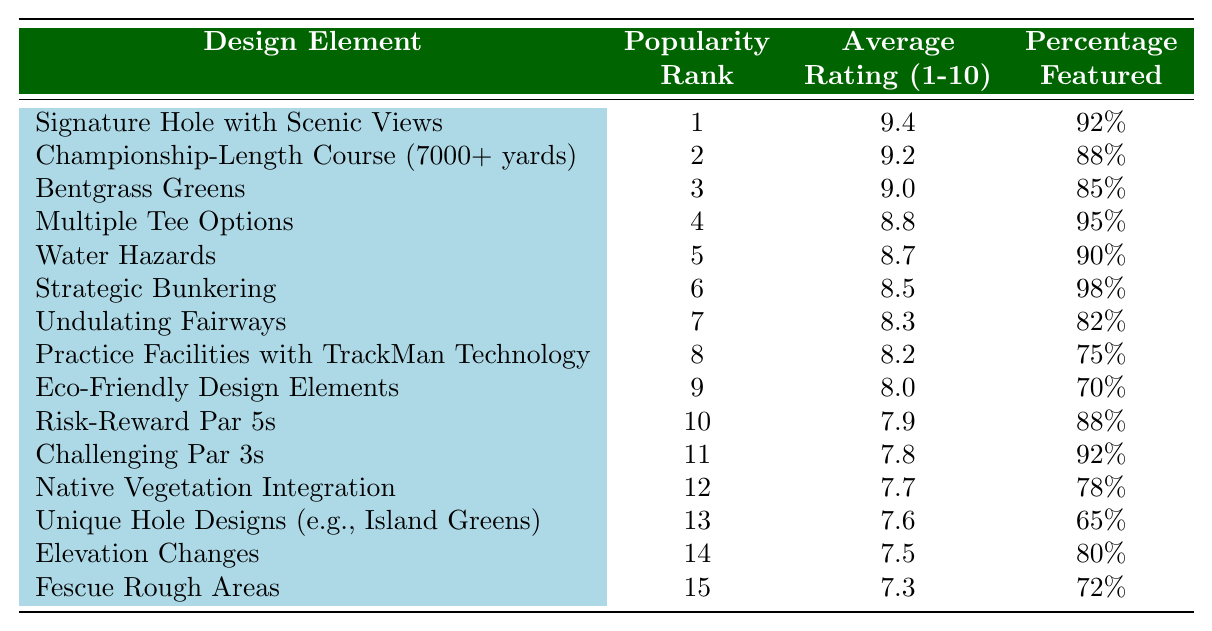What is the highest ranked design element? The highest rank in the table is 1, which corresponds to the design element "Signature Hole with Scenic Views."
Answer: Signature Hole with Scenic Views What percentage of high-end courses feature "Strategic Bunkering"? By examining the table, "Strategic Bunkering" has a percentage of 98%.
Answer: 98% What is the average rating of the top three design elements? The average rating of the top three design elements is calculated as (9.4 + 9.2 + 9.0) / 3 = 9.2.
Answer: 9.2 Is "Eco-Friendly Design Elements" more popular than "Practice Facilities with TrackMan Technology"? "Eco-Friendly Design Elements" has a rank of 9, while "Practice Facilities with TrackMan Technology" has a rank of 8, indicating it is less popular.
Answer: No How many design elements have an average rating above 8.0? By reviewing the average ratings, we see that there are 8 design elements with ratings above 8.0.
Answer: 8 What is the percentage difference in features between "Fescue Rough Areas" and "Strategic Bunkering"? "Fescue Rough Areas" features 72%, while "Strategic Bunkering" features 98%. The percentage difference is 98% - 72% = 26%.
Answer: 26% What is the rank of "Undulating Fairways"? The table shows that "Undulating Fairways" has a rank of 7.
Answer: 7 Do more than 75% of high-end courses feature "Water Hazards"? The table indicates that "Water Hazards" features 90%, which is indeed more than 75%.
Answer: Yes Which design element has the lowest average rating? The design element with the lowest average rating is "Fescue Rough Areas," rated at 7.3.
Answer: Fescue Rough Areas What is the combined average rating of the design elements ranked from 10 to 15? To find the combined average, we sum the ratings (7.9 + 7.8 + 7.7 + 7.6 + 7.5 + 7.3) = 45.8 and divide by 6 = 7.633, approximately 7.6.
Answer: 7.6 